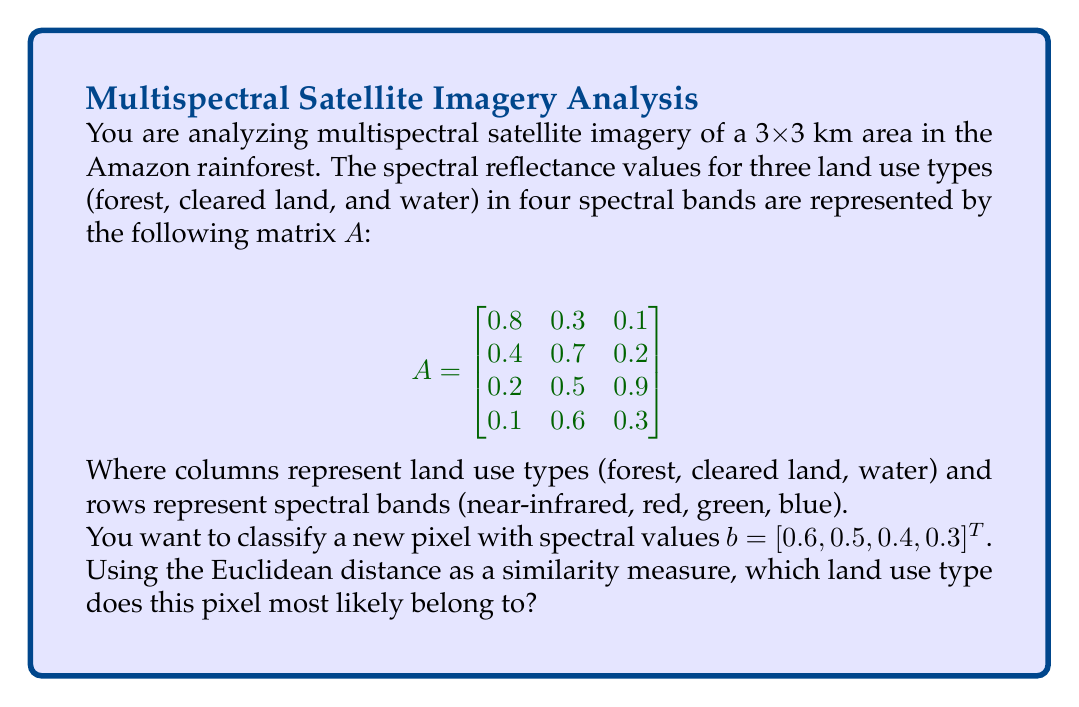Provide a solution to this math problem. To classify the new pixel, we need to calculate the Euclidean distance between the pixel's spectral values and each land use type's spectral signature. The land use type with the smallest distance will be the most likely classification.

Step 1: Extract spectral signatures for each land use type from matrix $A$:
- Forest: $f = [0.8, 0.4, 0.2, 0.1]^T$
- Cleared land: $c = [0.3, 0.7, 0.5, 0.6]^T$
- Water: $w = [0.1, 0.2, 0.9, 0.3]^T$

Step 2: Calculate Euclidean distances using the formula:
$$d = \sqrt{\sum_{i=1}^n (x_i - y_i)^2}$$

For forest:
$$d_f = \sqrt{(0.6-0.8)^2 + (0.5-0.4)^2 + (0.4-0.2)^2 + (0.3-0.1)^2} = 0.3742$$

For cleared land:
$$d_c = \sqrt{(0.6-0.3)^2 + (0.5-0.7)^2 + (0.4-0.5)^2 + (0.3-0.6)^2} = 0.4583$$

For water:
$$d_w = \sqrt{(0.6-0.1)^2 + (0.5-0.2)^2 + (0.4-0.9)^2 + (0.3-0.3)^2} = 0.8602$$

Step 3: Compare distances:
$d_f = 0.3742$ (smallest)
$d_c = 0.4583$
$d_w = 0.8602$

The smallest distance is for the forest class, so the pixel is most likely to belong to the forest land use type.
Answer: Forest 